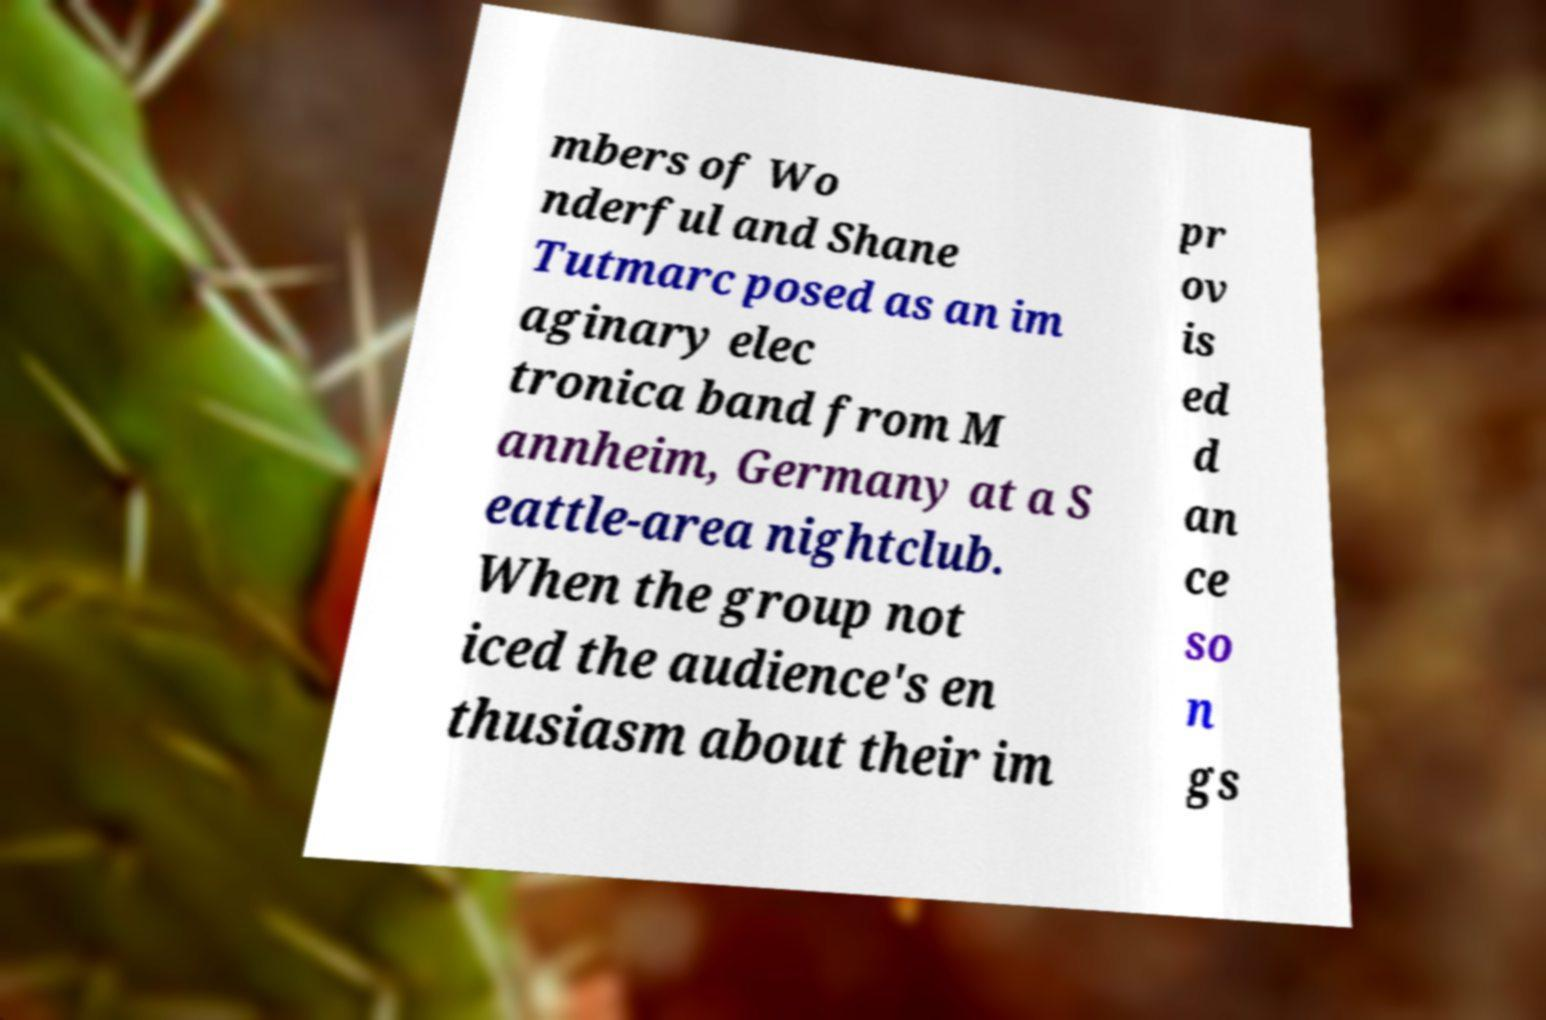Please read and relay the text visible in this image. What does it say? mbers of Wo nderful and Shane Tutmarc posed as an im aginary elec tronica band from M annheim, Germany at a S eattle-area nightclub. When the group not iced the audience's en thusiasm about their im pr ov is ed d an ce so n gs 